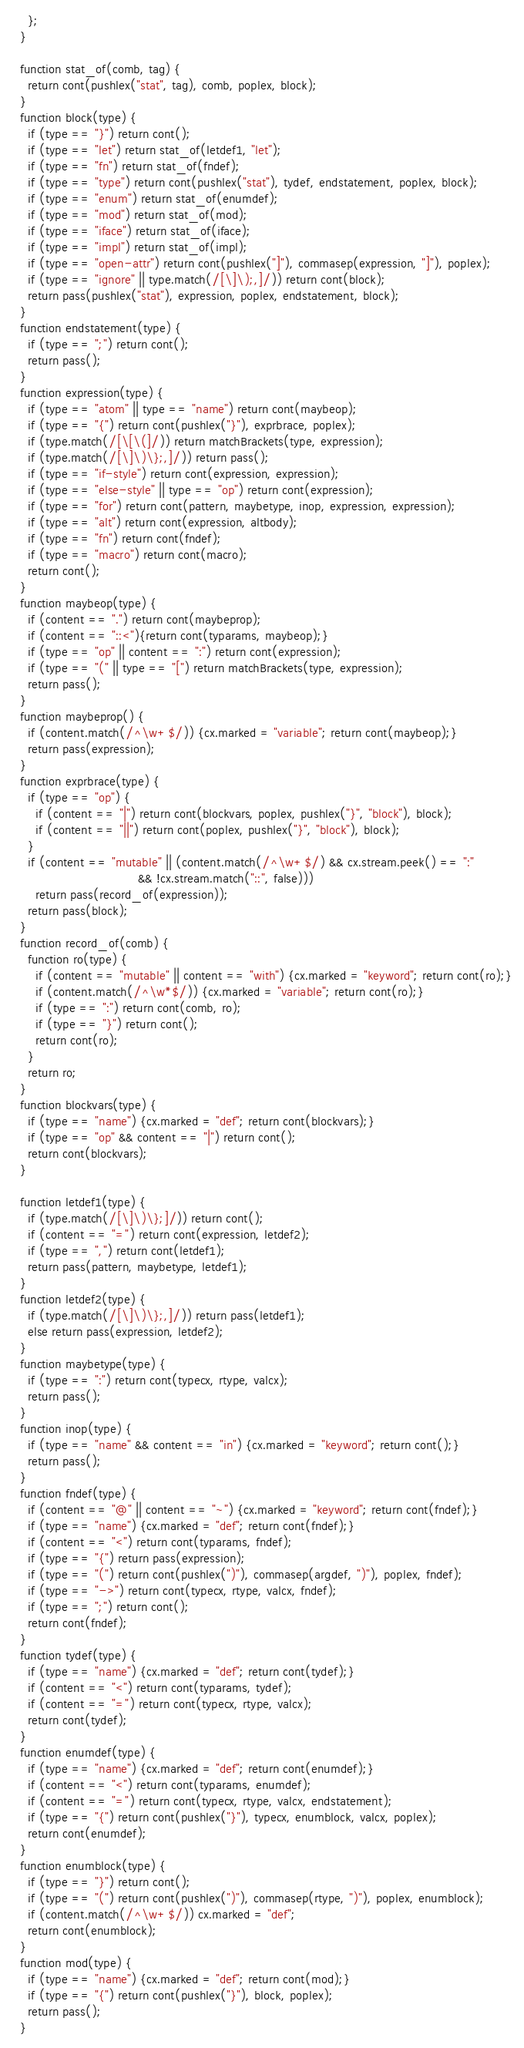Convert code to text. <code><loc_0><loc_0><loc_500><loc_500><_JavaScript_>    };
  }

  function stat_of(comb, tag) {
    return cont(pushlex("stat", tag), comb, poplex, block);
  }
  function block(type) {
    if (type == "}") return cont();
    if (type == "let") return stat_of(letdef1, "let");
    if (type == "fn") return stat_of(fndef);
    if (type == "type") return cont(pushlex("stat"), tydef, endstatement, poplex, block);
    if (type == "enum") return stat_of(enumdef);
    if (type == "mod") return stat_of(mod);
    if (type == "iface") return stat_of(iface);
    if (type == "impl") return stat_of(impl);
    if (type == "open-attr") return cont(pushlex("]"), commasep(expression, "]"), poplex);
    if (type == "ignore" || type.match(/[\]\);,]/)) return cont(block);
    return pass(pushlex("stat"), expression, poplex, endstatement, block);
  }
  function endstatement(type) {
    if (type == ";") return cont();
    return pass();
  }
  function expression(type) {
    if (type == "atom" || type == "name") return cont(maybeop);
    if (type == "{") return cont(pushlex("}"), exprbrace, poplex);
    if (type.match(/[\[\(]/)) return matchBrackets(type, expression);
    if (type.match(/[\]\)\};,]/)) return pass();
    if (type == "if-style") return cont(expression, expression);
    if (type == "else-style" || type == "op") return cont(expression);
    if (type == "for") return cont(pattern, maybetype, inop, expression, expression);
    if (type == "alt") return cont(expression, altbody);
    if (type == "fn") return cont(fndef);
    if (type == "macro") return cont(macro);
    return cont();
  }
  function maybeop(type) {
    if (content == ".") return cont(maybeprop);
    if (content == "::<"){return cont(typarams, maybeop);}
    if (type == "op" || content == ":") return cont(expression);
    if (type == "(" || type == "[") return matchBrackets(type, expression);
    return pass();
  }
  function maybeprop() {
    if (content.match(/^\w+$/)) {cx.marked = "variable"; return cont(maybeop);}
    return pass(expression);
  }
  function exprbrace(type) {
    if (type == "op") {
      if (content == "|") return cont(blockvars, poplex, pushlex("}", "block"), block);
      if (content == "||") return cont(poplex, pushlex("}", "block"), block);
    }
    if (content == "mutable" || (content.match(/^\w+$/) && cx.stream.peek() == ":"
                                 && !cx.stream.match("::", false)))
      return pass(record_of(expression));
    return pass(block);
  }
  function record_of(comb) {
    function ro(type) {
      if (content == "mutable" || content == "with") {cx.marked = "keyword"; return cont(ro);}
      if (content.match(/^\w*$/)) {cx.marked = "variable"; return cont(ro);}
      if (type == ":") return cont(comb, ro);
      if (type == "}") return cont();
      return cont(ro);
    }
    return ro;
  }
  function blockvars(type) {
    if (type == "name") {cx.marked = "def"; return cont(blockvars);}
    if (type == "op" && content == "|") return cont();
    return cont(blockvars);
  }

  function letdef1(type) {
    if (type.match(/[\]\)\};]/)) return cont();
    if (content == "=") return cont(expression, letdef2);
    if (type == ",") return cont(letdef1);
    return pass(pattern, maybetype, letdef1);
  }
  function letdef2(type) {
    if (type.match(/[\]\)\};,]/)) return pass(letdef1);
    else return pass(expression, letdef2);
  }
  function maybetype(type) {
    if (type == ":") return cont(typecx, rtype, valcx);
    return pass();
  }
  function inop(type) {
    if (type == "name" && content == "in") {cx.marked = "keyword"; return cont();}
    return pass();
  }
  function fndef(type) {
    if (content == "@" || content == "~") {cx.marked = "keyword"; return cont(fndef);}
    if (type == "name") {cx.marked = "def"; return cont(fndef);}
    if (content == "<") return cont(typarams, fndef);
    if (type == "{") return pass(expression);
    if (type == "(") return cont(pushlex(")"), commasep(argdef, ")"), poplex, fndef);
    if (type == "->") return cont(typecx, rtype, valcx, fndef);
    if (type == ";") return cont();
    return cont(fndef);
  }
  function tydef(type) {
    if (type == "name") {cx.marked = "def"; return cont(tydef);}
    if (content == "<") return cont(typarams, tydef);
    if (content == "=") return cont(typecx, rtype, valcx);
    return cont(tydef);
  }
  function enumdef(type) {
    if (type == "name") {cx.marked = "def"; return cont(enumdef);}
    if (content == "<") return cont(typarams, enumdef);
    if (content == "=") return cont(typecx, rtype, valcx, endstatement);
    if (type == "{") return cont(pushlex("}"), typecx, enumblock, valcx, poplex);
    return cont(enumdef);
  }
  function enumblock(type) {
    if (type == "}") return cont();
    if (type == "(") return cont(pushlex(")"), commasep(rtype, ")"), poplex, enumblock);
    if (content.match(/^\w+$/)) cx.marked = "def";
    return cont(enumblock);
  }
  function mod(type) {
    if (type == "name") {cx.marked = "def"; return cont(mod);}
    if (type == "{") return cont(pushlex("}"), block, poplex);
    return pass();
  }</code> 